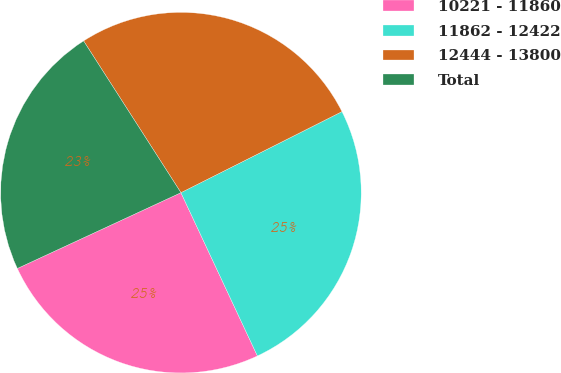Convert chart. <chart><loc_0><loc_0><loc_500><loc_500><pie_chart><fcel>10221 - 11860<fcel>11862 - 12422<fcel>12444 - 13800<fcel>Total<nl><fcel>25.07%<fcel>25.45%<fcel>26.66%<fcel>22.83%<nl></chart> 